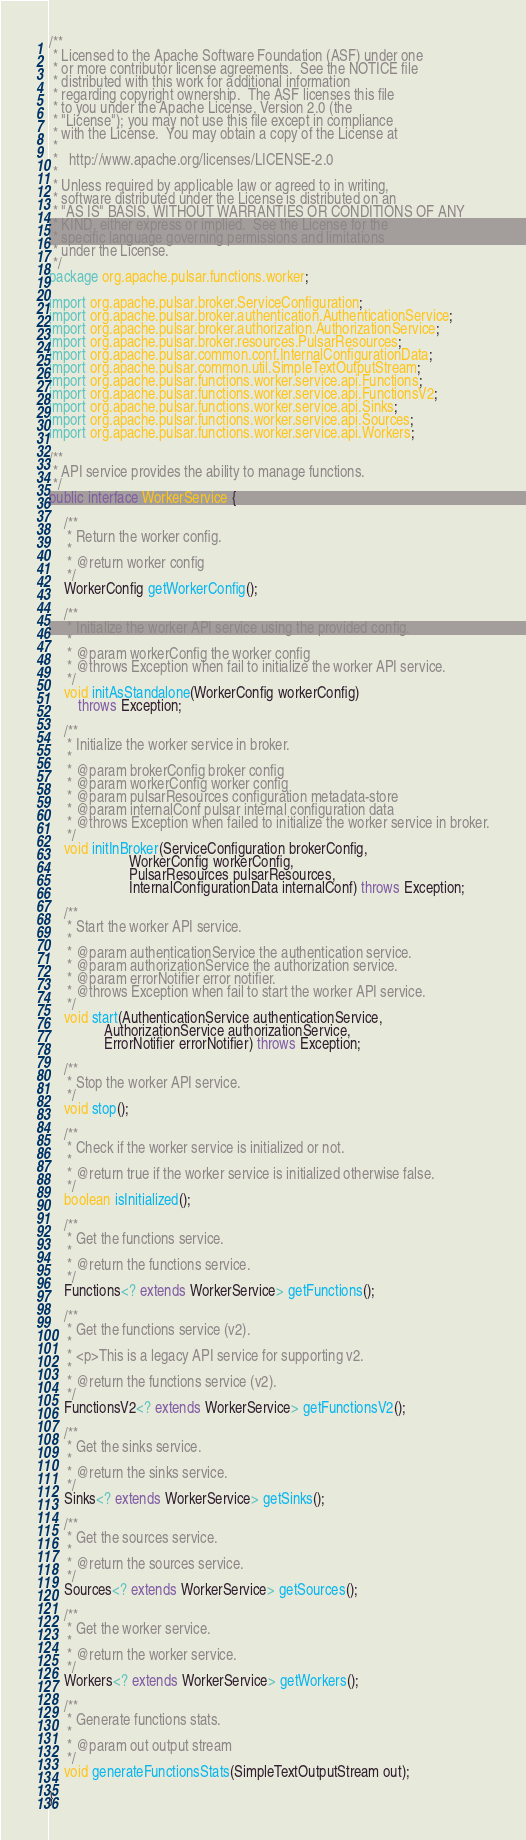Convert code to text. <code><loc_0><loc_0><loc_500><loc_500><_Java_>/**
 * Licensed to the Apache Software Foundation (ASF) under one
 * or more contributor license agreements.  See the NOTICE file
 * distributed with this work for additional information
 * regarding copyright ownership.  The ASF licenses this file
 * to you under the Apache License, Version 2.0 (the
 * "License"); you may not use this file except in compliance
 * with the License.  You may obtain a copy of the License at
 *
 *   http://www.apache.org/licenses/LICENSE-2.0
 *
 * Unless required by applicable law or agreed to in writing,
 * software distributed under the License is distributed on an
 * "AS IS" BASIS, WITHOUT WARRANTIES OR CONDITIONS OF ANY
 * KIND, either express or implied.  See the License for the
 * specific language governing permissions and limitations
 * under the License.
 */
package org.apache.pulsar.functions.worker;

import org.apache.pulsar.broker.ServiceConfiguration;
import org.apache.pulsar.broker.authentication.AuthenticationService;
import org.apache.pulsar.broker.authorization.AuthorizationService;
import org.apache.pulsar.broker.resources.PulsarResources;
import org.apache.pulsar.common.conf.InternalConfigurationData;
import org.apache.pulsar.common.util.SimpleTextOutputStream;
import org.apache.pulsar.functions.worker.service.api.Functions;
import org.apache.pulsar.functions.worker.service.api.FunctionsV2;
import org.apache.pulsar.functions.worker.service.api.Sinks;
import org.apache.pulsar.functions.worker.service.api.Sources;
import org.apache.pulsar.functions.worker.service.api.Workers;

/**
 * API service provides the ability to manage functions.
 */
public interface WorkerService {

    /**
     * Return the worker config.
     *
     * @return worker config
     */
    WorkerConfig getWorkerConfig();

    /**
     * Initialize the worker API service using the provided config.
     *
     * @param workerConfig the worker config
     * @throws Exception when fail to initialize the worker API service.
     */
    void initAsStandalone(WorkerConfig workerConfig)
        throws Exception;

    /**
     * Initialize the worker service in broker.
     *
     * @param brokerConfig broker config
     * @param workerConfig worker config
     * @param pulsarResources configuration metadata-store
     * @param internalConf pulsar internal configuration data
     * @throws Exception when failed to initialize the worker service in broker.
     */
    void initInBroker(ServiceConfiguration brokerConfig,
                      WorkerConfig workerConfig,
                      PulsarResources pulsarResources,
                      InternalConfigurationData internalConf) throws Exception;

    /**
     * Start the worker API service.
     *
     * @param authenticationService the authentication service.
     * @param authorizationService the authorization service.
     * @param errorNotifier error notifier.
     * @throws Exception when fail to start the worker API service.
     */
    void start(AuthenticationService authenticationService,
               AuthorizationService authorizationService,
               ErrorNotifier errorNotifier) throws Exception;

    /**
     * Stop the worker API service.
     */
    void stop();

    /**
     * Check if the worker service is initialized or not.
     *
     * @return true if the worker service is initialized otherwise false.
     */
    boolean isInitialized();

    /**
     * Get the functions service.
     *
     * @return the functions service.
     */
    Functions<? extends WorkerService> getFunctions();

    /**
     * Get the functions service (v2).
     *
     * <p>This is a legacy API service for supporting v2.
     *
     * @return the functions service (v2).
     */
    FunctionsV2<? extends WorkerService> getFunctionsV2();

    /**
     * Get the sinks service.
     *
     * @return the sinks service.
     */
    Sinks<? extends WorkerService> getSinks();

    /**
     * Get the sources service.
     *
     * @return the sources service.
     */
    Sources<? extends WorkerService> getSources();

    /**
     * Get the worker service.
     *
     * @return the worker service.
     */
    Workers<? extends WorkerService> getWorkers();

    /**
     * Generate functions stats.
     *
     * @param out output stream
     */
    void generateFunctionsStats(SimpleTextOutputStream out);

}
</code> 